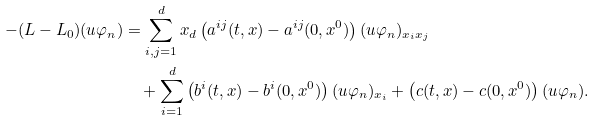<formula> <loc_0><loc_0><loc_500><loc_500>- ( L - L _ { 0 } ) ( u \varphi _ { n } ) & = \sum _ { i , j = 1 } ^ { d } x _ { d } \left ( a ^ { i j } ( t , x ) - a ^ { i j } ( 0 , x ^ { 0 } ) \right ) ( u \varphi _ { n } ) _ { x _ { i } x _ { j } } \\ & \quad + \sum _ { i = 1 } ^ { d } \left ( b ^ { i } ( t , x ) - b ^ { i } ( 0 , x ^ { 0 } ) \right ) ( u \varphi _ { n } ) _ { x _ { i } } + \left ( c ( t , x ) - c ( 0 , x ^ { 0 } ) \right ) ( u \varphi _ { n } ) .</formula> 